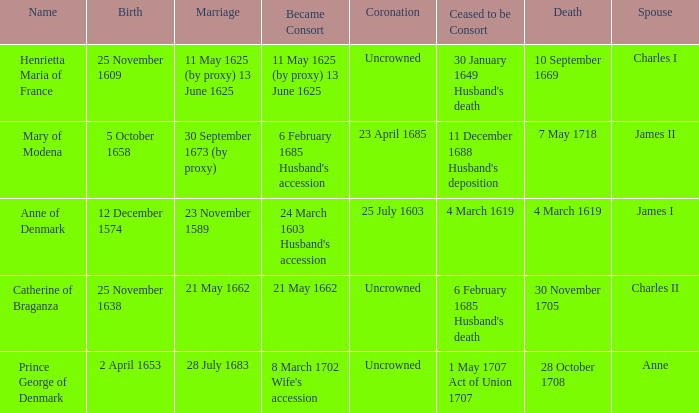On what date did James II take a consort? 6 February 1685 Husband's accession. 